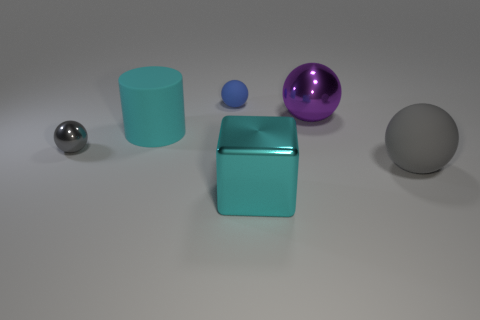Add 3 blocks. How many objects exist? 9 Subtract all spheres. How many objects are left? 2 Subtract all large yellow matte objects. Subtract all large purple metallic balls. How many objects are left? 5 Add 2 metallic cubes. How many metallic cubes are left? 3 Add 2 small blue matte balls. How many small blue matte balls exist? 3 Subtract 1 cyan cylinders. How many objects are left? 5 